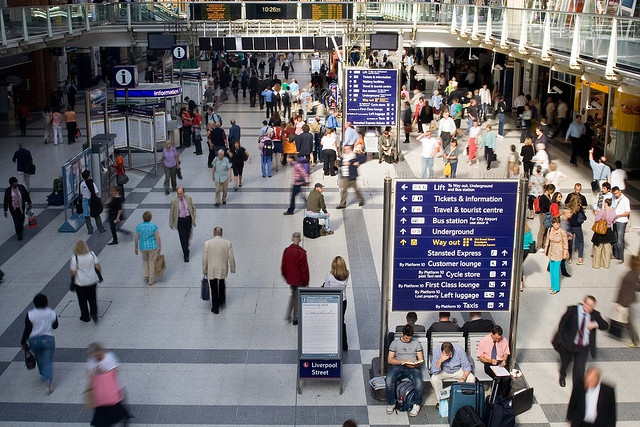Describe the objects in this image and their specific colors. I can see people in black, gray, lightgray, and darkgray tones, people in black, gray, and darkgray tones, people in black, gray, darkgray, and tan tones, people in black, gray, brown, and violet tones, and people in black, darkgray, gray, and navy tones in this image. 